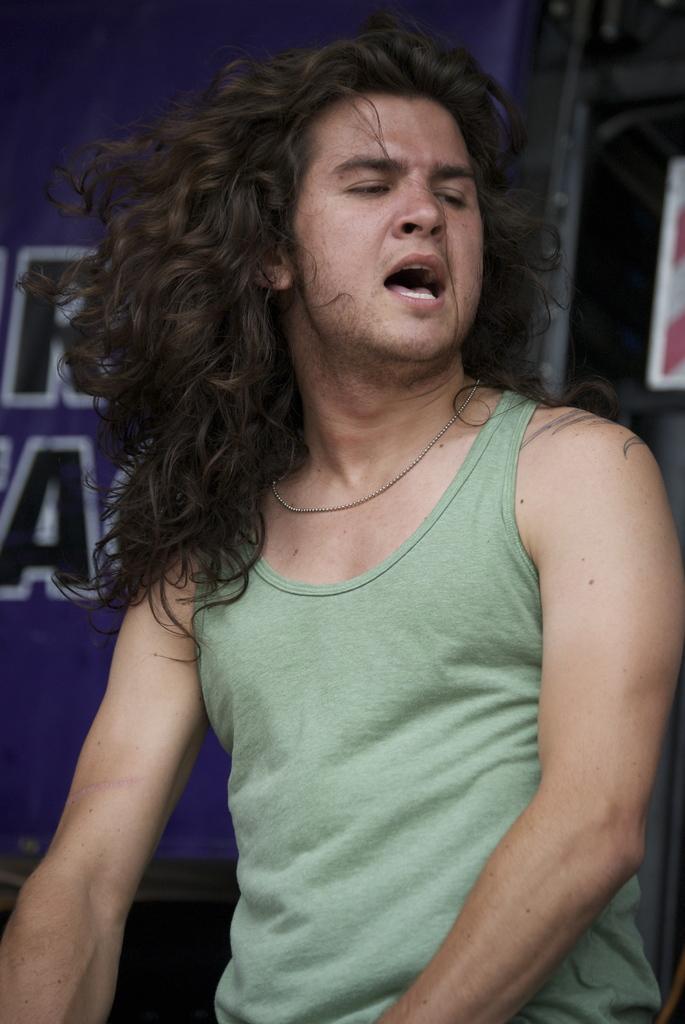In one or two sentences, can you explain what this image depicts? In the center of the image we can see a man. In the background there is a board. 